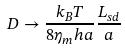Convert formula to latex. <formula><loc_0><loc_0><loc_500><loc_500>D \rightarrow \frac { k _ { B } T } { 8 \eta _ { m } h a } \frac { L _ { s d } } { a }</formula> 